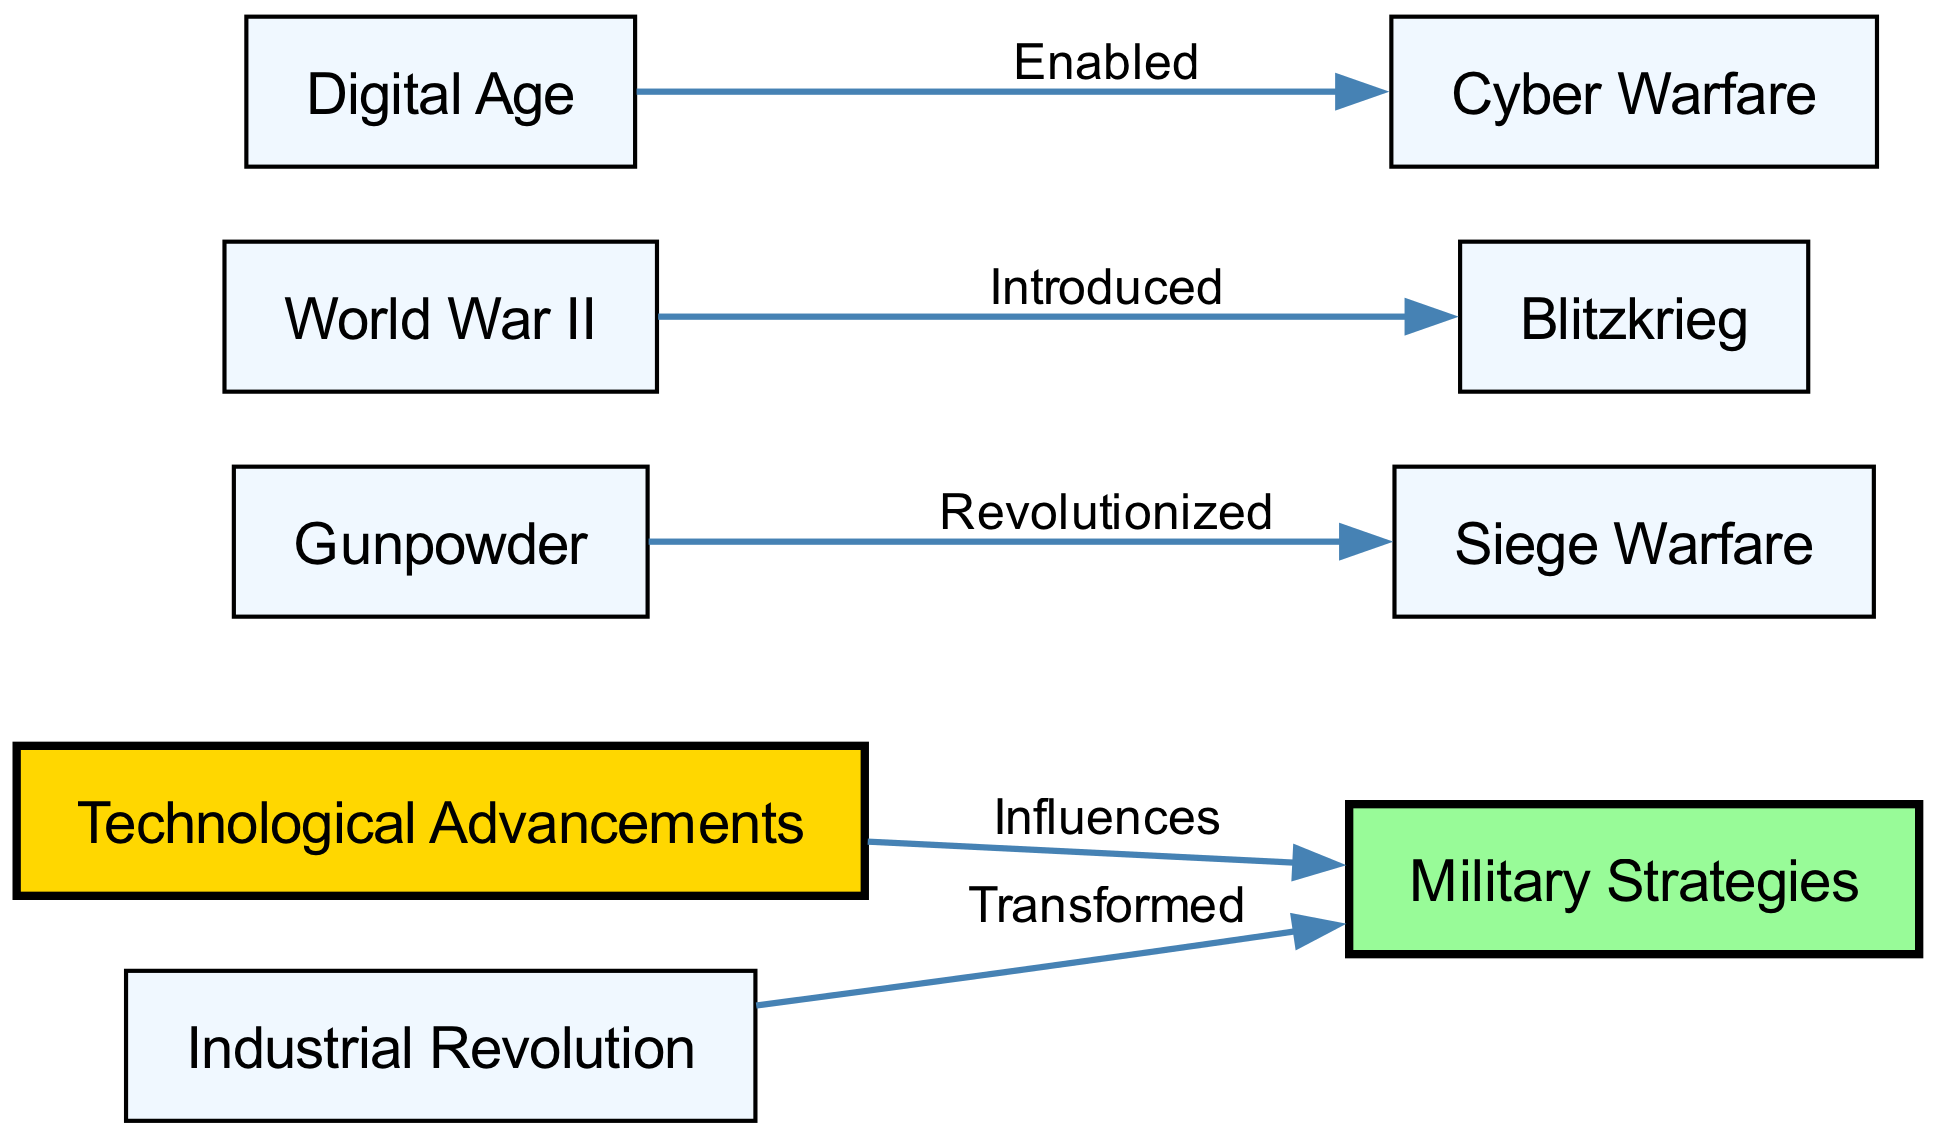What is the main theme of the diagram? The theme of the diagram revolves around the relationship between technological advancements and military strategies throughout history. It emphasizes how various technological changes have significantly influenced military approaches over time.
Answer: Technological advancements How many nodes are represented in the diagram? To determine the number of nodes, we count the items listed under the "nodes" section in the data. There are a total of 9 nodes.
Answer: 9 What did gunpowder revolutionize? According to the diagram, gunpowder revolutionized siege warfare, illustrating its direct impact on a specific military strategy.
Answer: Siege Warfare Which technological advancement is linked to the concept of cyber warfare? The diagram shows that the digital age is the technological advancement that enabled cyber warfare, indicating its role in modern military strategies.
Answer: Digital Age What military strategy was introduced during World War II? The diagram clearly states that Blitzkrieg was introduced during World War II, reflecting a significant evolution in military tactics during that time.
Answer: Blitzkrieg How did the Industrial Revolution affect military strategies? According to the diagram, the Industrial Revolution transformed military strategies, indicating a major shift in how wars were conducted due to advances in technology and manufacturing.
Answer: Transformed Which advancement is a direct result of technological influences? The diagram indicates that military strategies are directly influenced by technological advancements, showcasing the interdependence of these two concepts.
Answer: Influences What is the relationship between the Digital Age and its impact on warfare? The diagram establishes that the Digital Age enabled cyber warfare, highlighting how advancements in technology provide new avenues for military operations.
Answer: Enabled 